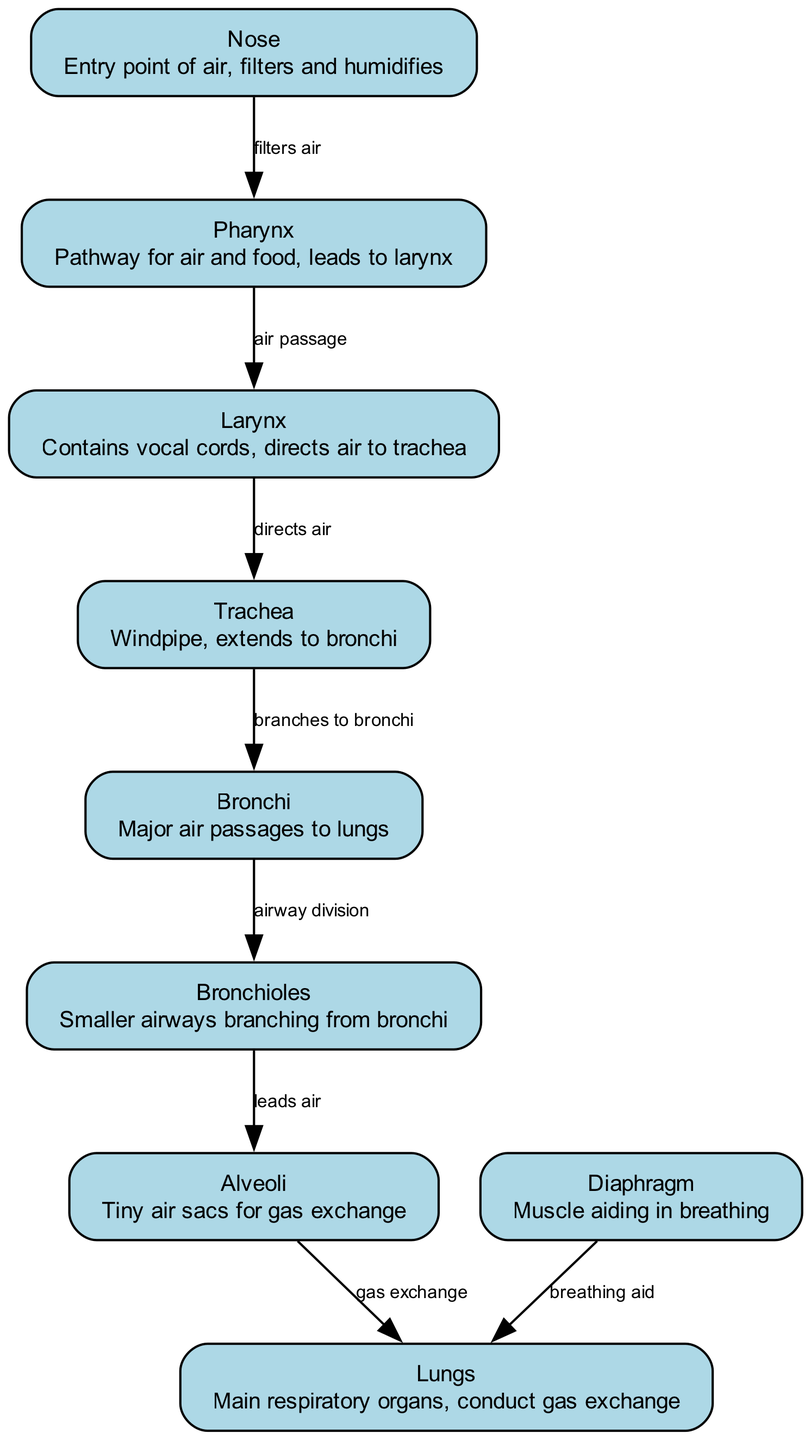What is the entry point of air into the respiratory system? The diagram identifies the "Nose" as the entry point for air, highlighting its role in filtering and humidifying the incoming air.
Answer: Nose Which structure leads from the pharynx to the trachea? The diagram indicates the "Larynx" as the pathway that connects the pharynx to the trachea, serving as a crucial passage for air.
Answer: Larynx How many major air passages are indicated in the diagram? The diagram shows "Bronchi" as the major air passages, and since there are no additional nodes labeled as major air passages, the answer is simply one (bronchi, multiple branches).
Answer: Bronchi What structure is responsible for gas exchange? The diagram points to "Alveoli" where the gas exchange takes place, indicating these tiny air sacs facilitate the exchange of oxygen and carbon dioxide.
Answer: Alveoli Which muscle aids in breathing? The "Diaphragm" is identified in the diagram as the muscle that helps facilitate the breathing process by contracting and relaxing.
Answer: Diaphragm What is the pathway of air from the trachea to the lungs? Air travels from the "Trachea" to the "Bronchi," branches into "Bronchioles," and finally leads to the "Alveoli," where gas exchange occurs before it reaches the "Lungs."
Answer: Trachea to Bronchi to Bronchioles to Alveoli to Lungs What is the purpose of the pharynx according to the diagram? The diagram describes the "Pharynx" as a pathway for both air and food, emphasizing its dual function in the respiratory and digestive systems.
Answer: Pathway for air and food How does air flow from the bronchi to the lungs? According to the diagram, air moves from "Bronchi" to "Bronchioles," and then to "Alveoli," where it undergoes gas exchange before reaching the "Lungs."
Answer: Bronchi to Bronchioles to Alveoli to Lungs What does the larynx contain? The diagram specifies that the "Larynx" contains vocal cords, which are necessary for sound production, indicating its significance beyond air passage.
Answer: Vocal cords 